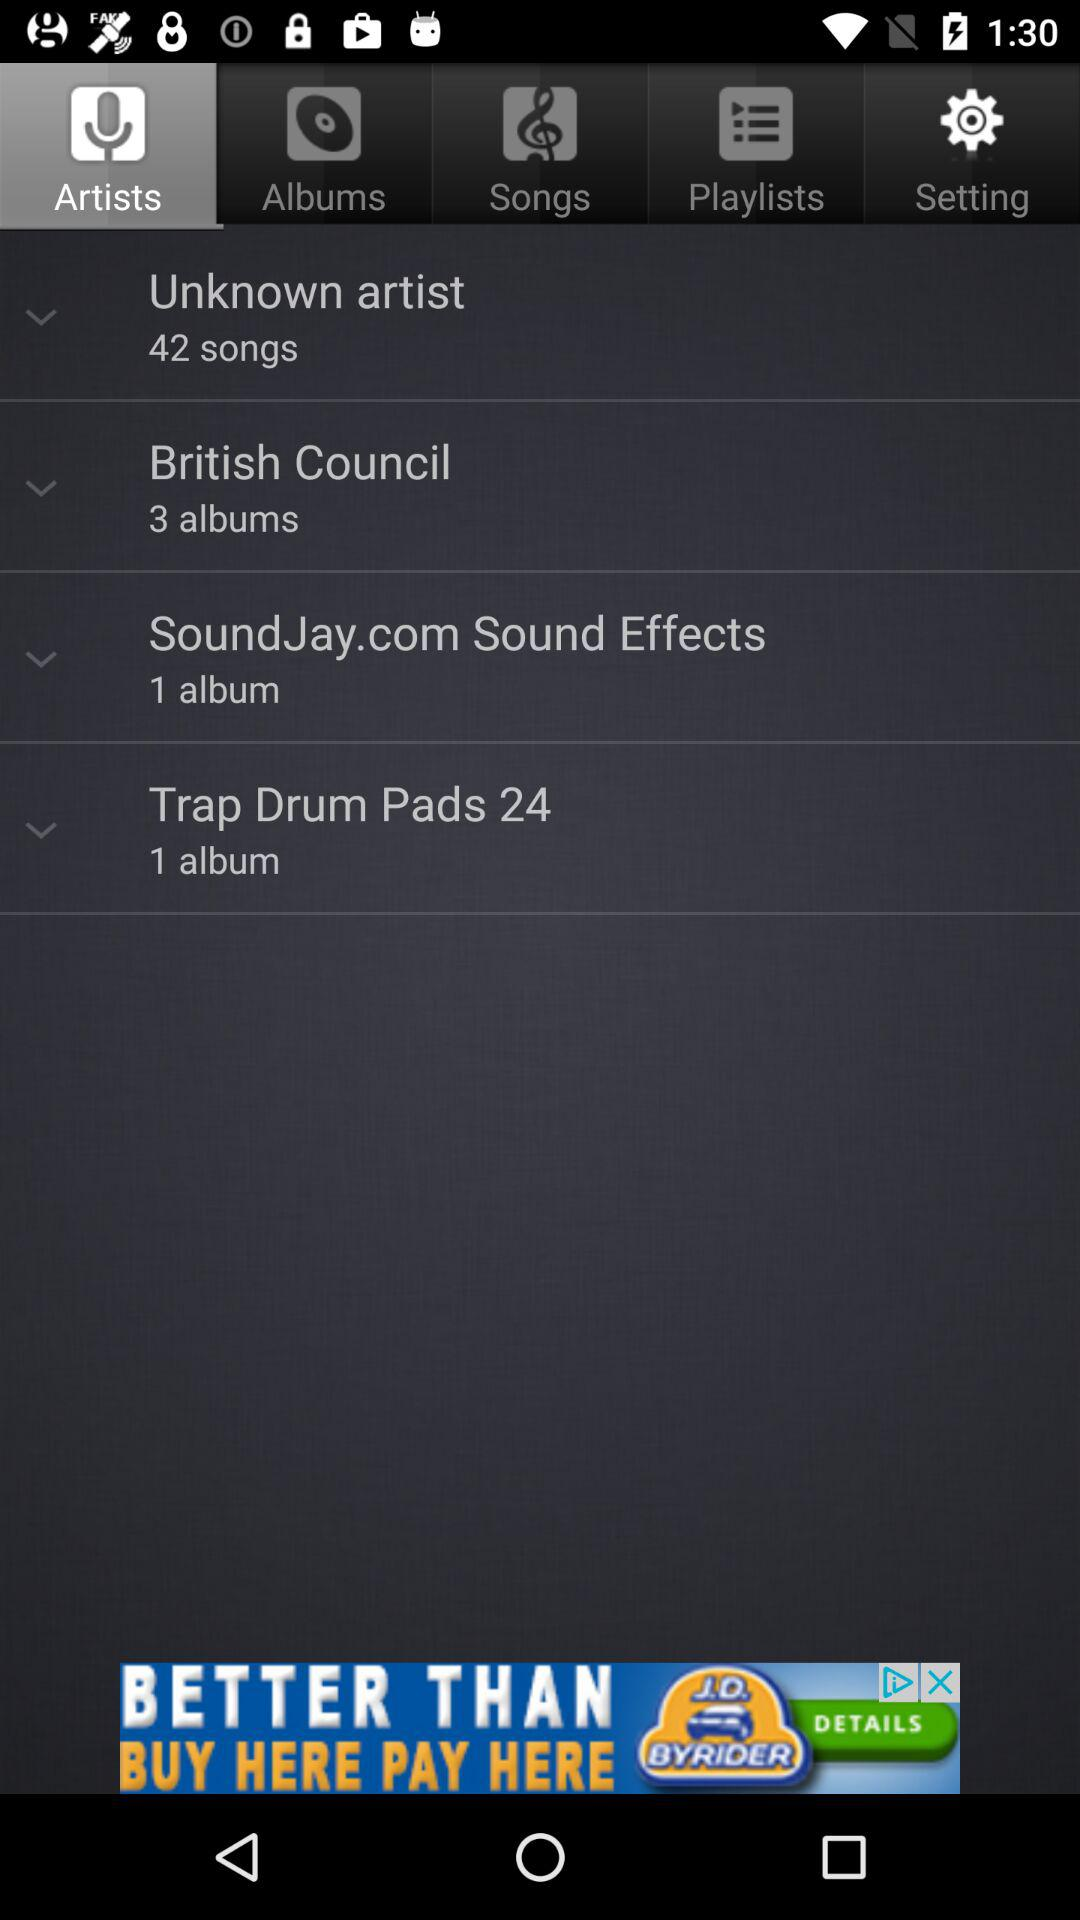How many albums are there in "British Council"? There are 3 alumbs. 